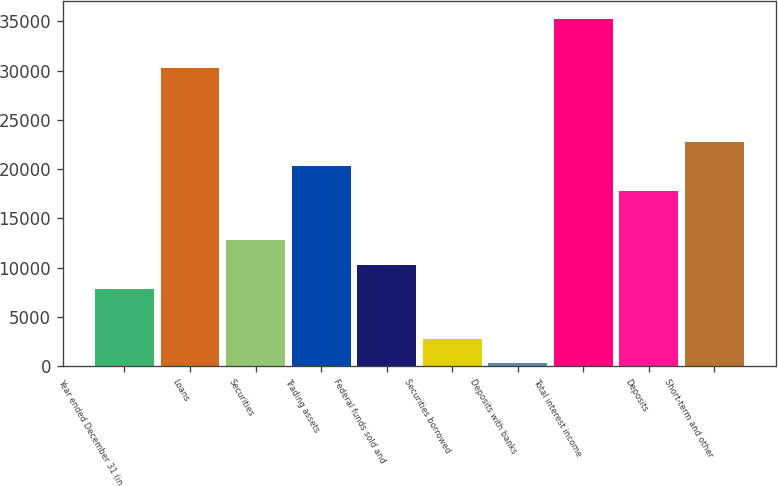Convert chart. <chart><loc_0><loc_0><loc_500><loc_500><bar_chart><fcel>Year ended December 31 (in<fcel>Loans<fcel>Securities<fcel>Trading assets<fcel>Federal funds sold and<fcel>Securities borrowed<fcel>Deposits with banks<fcel>Total interest income<fcel>Deposits<fcel>Short-term and other<nl><fcel>7797.3<fcel>30280.2<fcel>12793.5<fcel>20287.8<fcel>10295.4<fcel>2801.1<fcel>303<fcel>35276.4<fcel>17789.7<fcel>22785.9<nl></chart> 